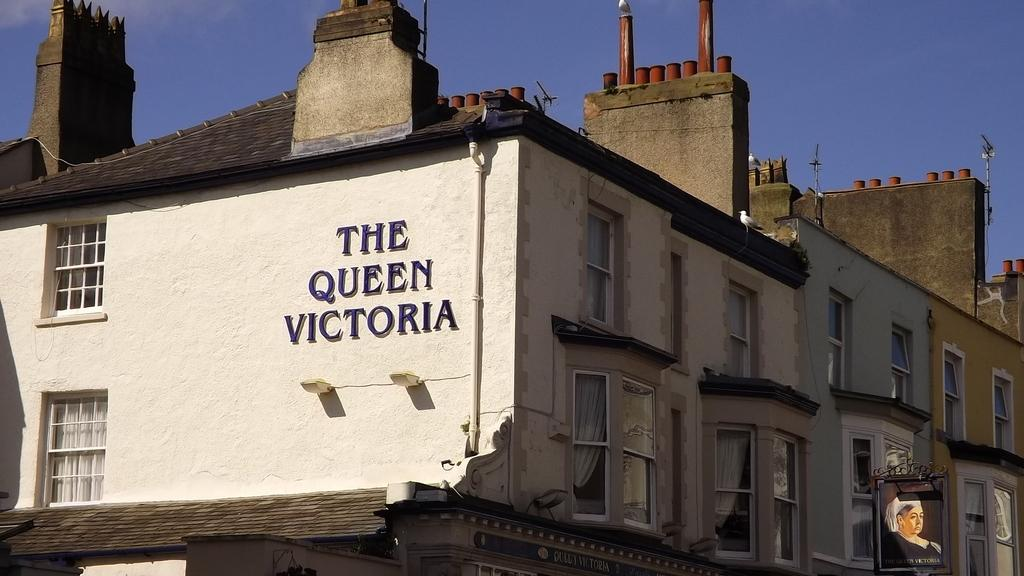What type of structure is present in the image? There is a building in the image. Where is the board located in the image? The board is in the bottom right of the image. What is visible at the top of the image? The sky is visible at the top of the image. Can you see any needles in the image? There are no needles present in the image. What part of the brain is visible in the image? There is no brain visible in the image. 